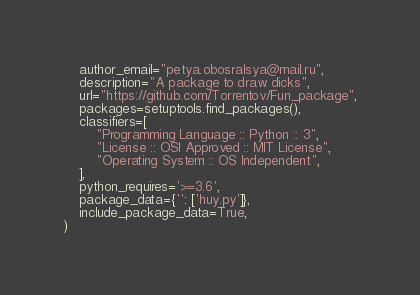Convert code to text. <code><loc_0><loc_0><loc_500><loc_500><_Python_>    author_email="petya.obosralsya@mail.ru",
    description="A package to draw dicks",
    url="https://github.com/Torrentov/Fun_package",
    packages=setuptools.find_packages(),
    classifiers=[
        "Programming Language :: Python :: 3",
        "License :: OSI Approved :: MIT License",
        "Operating System :: OS Independent",
    ],
    python_requires='>=3.6',
    package_data={'': ['huy.py']},
    include_package_data=True,
)
</code> 